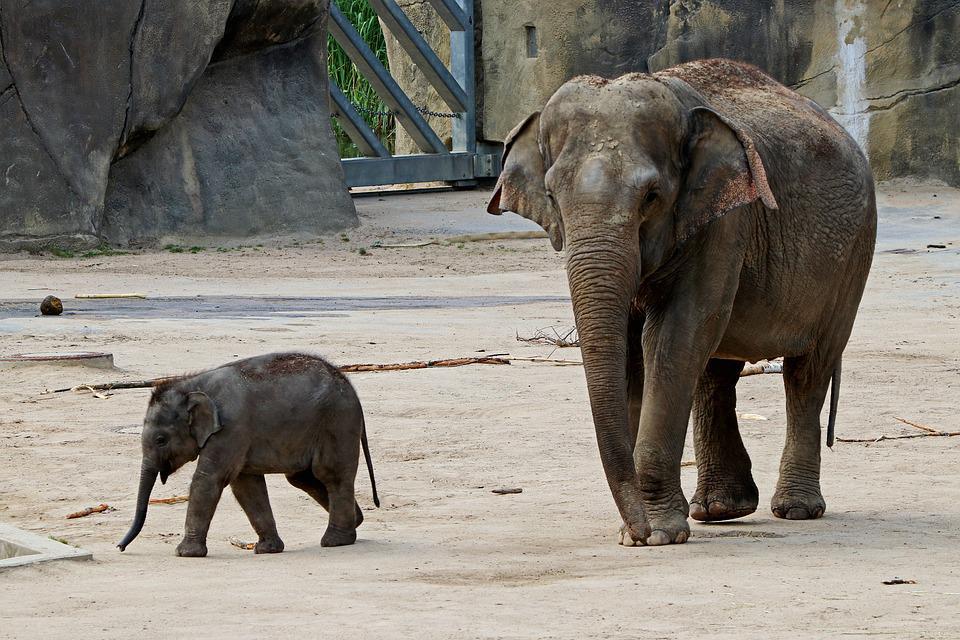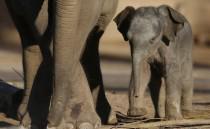The first image is the image on the left, the second image is the image on the right. Examine the images to the left and right. Is the description "Right image shows a forward facing baby elephant to the right of an adult elephant's legs." accurate? Answer yes or no. Yes. The first image is the image on the left, the second image is the image on the right. For the images displayed, is the sentence "All images show at least one young elephant." factually correct? Answer yes or no. Yes. 